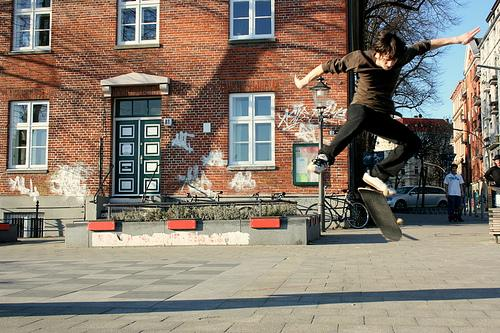The concrete planter has how many orange boards on the side? three 